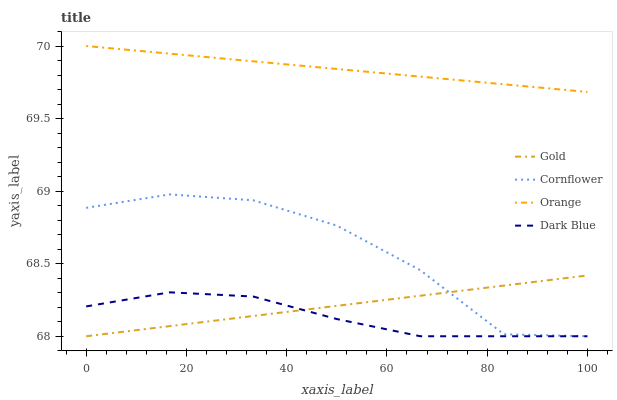Does Dark Blue have the minimum area under the curve?
Answer yes or no. Yes. Does Orange have the maximum area under the curve?
Answer yes or no. Yes. Does Cornflower have the minimum area under the curve?
Answer yes or no. No. Does Cornflower have the maximum area under the curve?
Answer yes or no. No. Is Orange the smoothest?
Answer yes or no. Yes. Is Cornflower the roughest?
Answer yes or no. Yes. Is Gold the smoothest?
Answer yes or no. No. Is Gold the roughest?
Answer yes or no. No. Does Cornflower have the lowest value?
Answer yes or no. Yes. Does Orange have the highest value?
Answer yes or no. Yes. Does Cornflower have the highest value?
Answer yes or no. No. Is Dark Blue less than Orange?
Answer yes or no. Yes. Is Orange greater than Gold?
Answer yes or no. Yes. Does Cornflower intersect Dark Blue?
Answer yes or no. Yes. Is Cornflower less than Dark Blue?
Answer yes or no. No. Is Cornflower greater than Dark Blue?
Answer yes or no. No. Does Dark Blue intersect Orange?
Answer yes or no. No. 